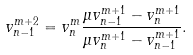<formula> <loc_0><loc_0><loc_500><loc_500>v _ { n - 1 } ^ { m + 2 } = v _ { n } ^ { m } \frac { \mu v _ { n - 1 } ^ { m + 1 } - v _ { n } ^ { m + 1 } } { \mu v _ { n } ^ { m + 1 } - v _ { n - 1 } ^ { m + 1 } } .</formula> 